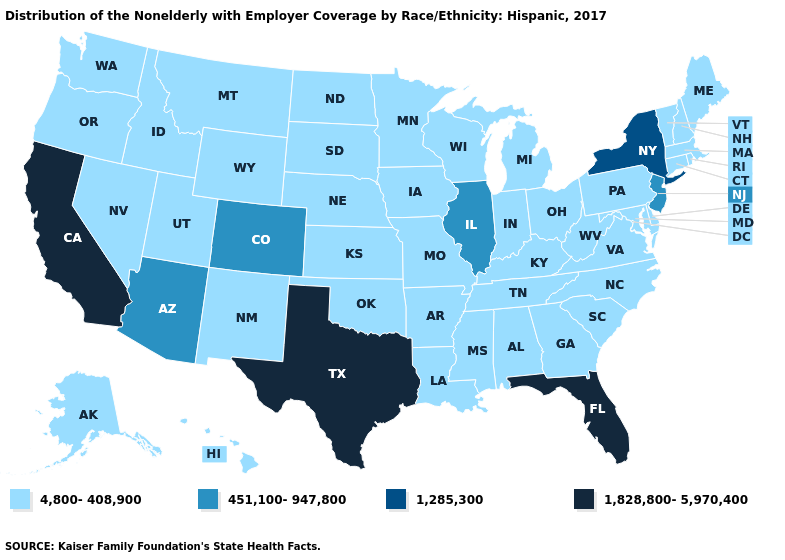Among the states that border Idaho , which have the lowest value?
Short answer required. Montana, Nevada, Oregon, Utah, Washington, Wyoming. What is the value of Colorado?
Concise answer only. 451,100-947,800. Name the states that have a value in the range 1,828,800-5,970,400?
Be succinct. California, Florida, Texas. What is the value of Florida?
Answer briefly. 1,828,800-5,970,400. What is the highest value in states that border Wyoming?
Write a very short answer. 451,100-947,800. How many symbols are there in the legend?
Give a very brief answer. 4. Among the states that border Tennessee , which have the highest value?
Concise answer only. Alabama, Arkansas, Georgia, Kentucky, Mississippi, Missouri, North Carolina, Virginia. Does Illinois have the lowest value in the MidWest?
Keep it brief. No. Among the states that border New York , which have the lowest value?
Be succinct. Connecticut, Massachusetts, Pennsylvania, Vermont. Among the states that border Michigan , which have the lowest value?
Keep it brief. Indiana, Ohio, Wisconsin. Name the states that have a value in the range 1,285,300?
Quick response, please. New York. What is the lowest value in the MidWest?
Short answer required. 4,800-408,900. Name the states that have a value in the range 1,828,800-5,970,400?
Concise answer only. California, Florida, Texas. Name the states that have a value in the range 1,285,300?
Give a very brief answer. New York. 